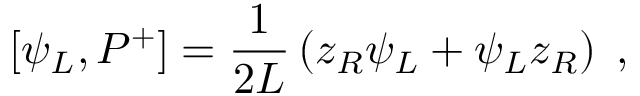Convert formula to latex. <formula><loc_0><loc_0><loc_500><loc_500>[ \psi _ { L } , P ^ { + } ] = { \frac { 1 } { 2 L } } \left ( z _ { R } \psi _ { L } + \psi _ { L } z _ { R } \right ) \, ,</formula> 